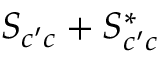Convert formula to latex. <formula><loc_0><loc_0><loc_500><loc_500>S _ { c ^ { \prime } c } + S _ { c ^ { \prime } c } ^ { * }</formula> 